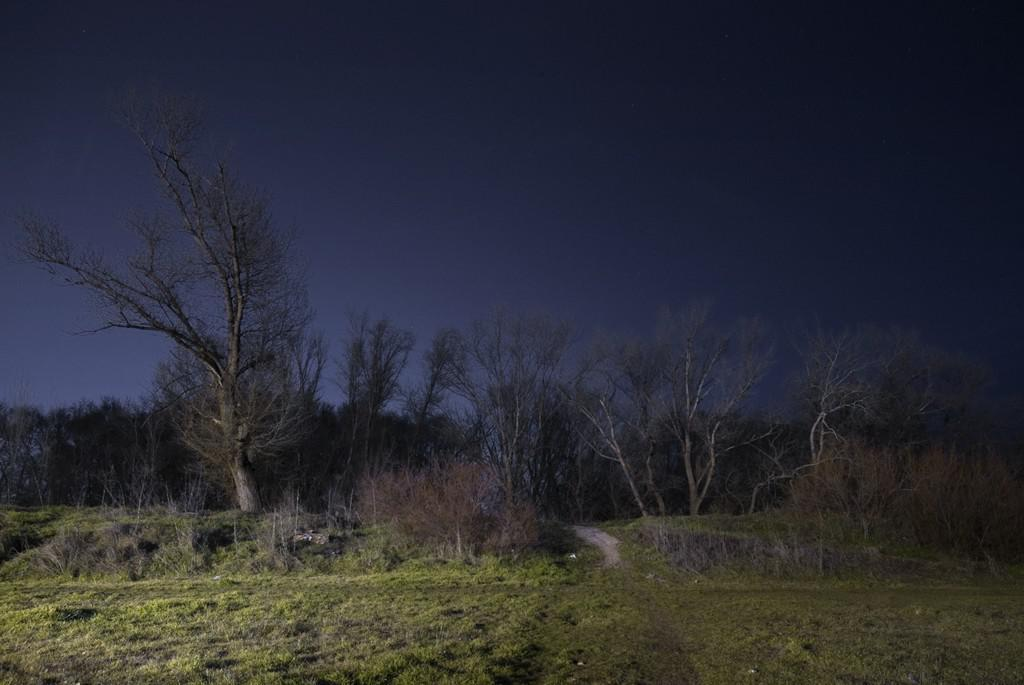What can be seen in the background of the image? There is sky and trees visible in the background of the image. What type of vegetation is present at the bottom portion of the picture? There is green grass at the bottom portion of the picture. What type of skirt is being worn by the lake in the image? There is no lake or skirt present in the image. How is the control panel being used in the image? There is no control panel present in the image. 